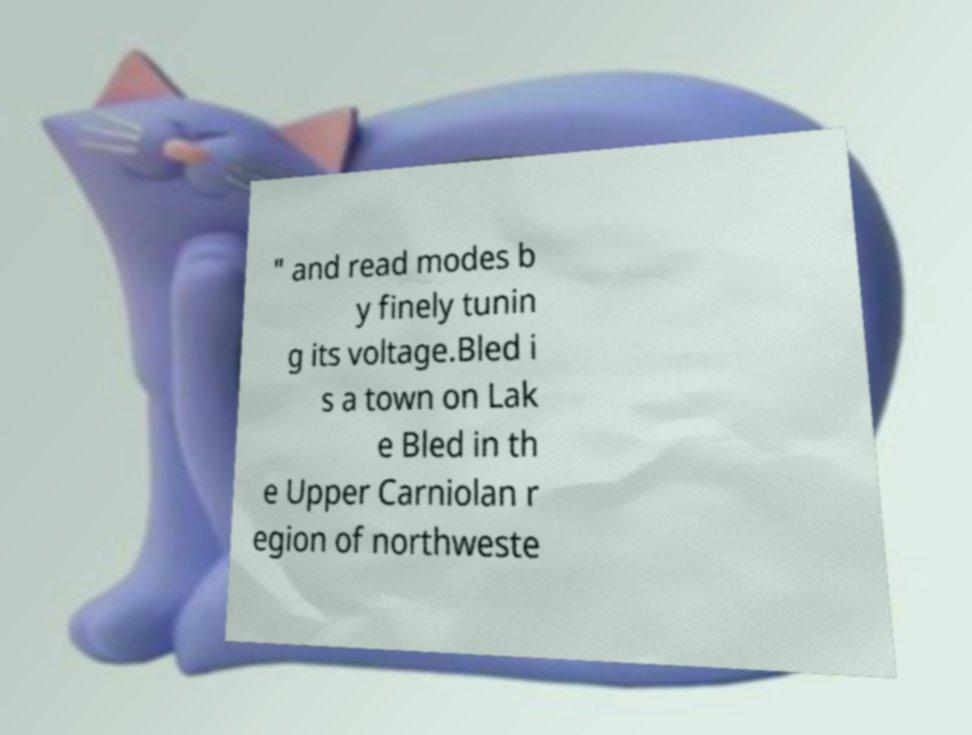I need the written content from this picture converted into text. Can you do that? " and read modes b y finely tunin g its voltage.Bled i s a town on Lak e Bled in th e Upper Carniolan r egion of northweste 